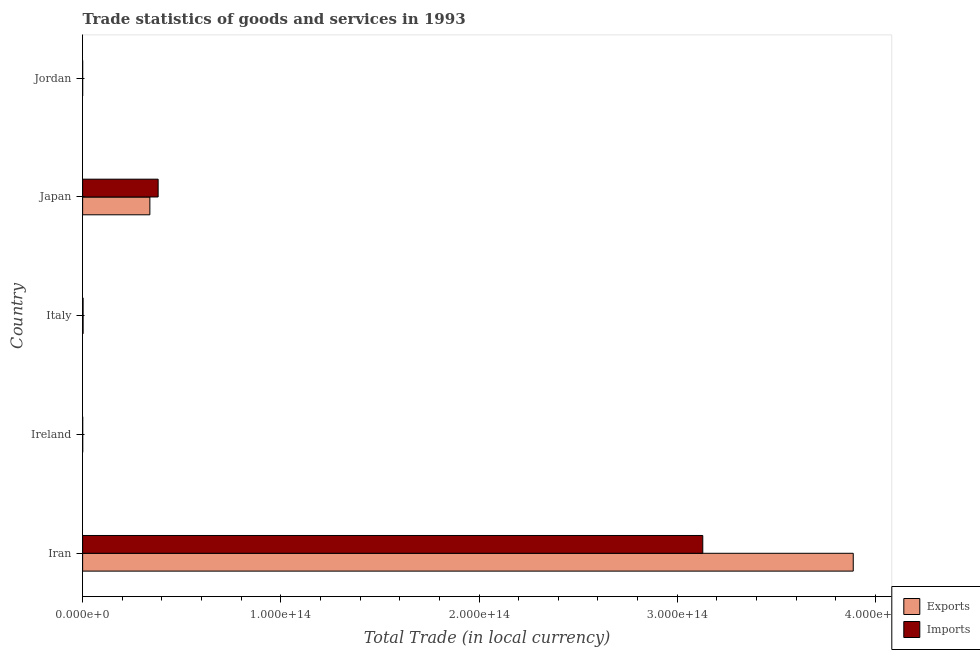How many different coloured bars are there?
Your response must be concise. 2. How many groups of bars are there?
Provide a short and direct response. 5. Are the number of bars on each tick of the Y-axis equal?
Your answer should be compact. Yes. How many bars are there on the 2nd tick from the top?
Provide a succinct answer. 2. How many bars are there on the 1st tick from the bottom?
Ensure brevity in your answer.  2. What is the label of the 4th group of bars from the top?
Keep it short and to the point. Ireland. In how many cases, is the number of bars for a given country not equal to the number of legend labels?
Provide a succinct answer. 0. What is the imports of goods and services in Jordan?
Provide a short and direct response. 3.05e+09. Across all countries, what is the maximum imports of goods and services?
Make the answer very short. 3.13e+14. Across all countries, what is the minimum export of goods and services?
Provide a short and direct response. 2.01e+09. In which country was the imports of goods and services maximum?
Keep it short and to the point. Iran. In which country was the export of goods and services minimum?
Your answer should be very brief. Jordan. What is the total export of goods and services in the graph?
Your answer should be very brief. 4.23e+14. What is the difference between the export of goods and services in Ireland and that in Italy?
Make the answer very short. -2.11e+11. What is the difference between the export of goods and services in Japan and the imports of goods and services in Jordan?
Give a very brief answer. 3.39e+13. What is the average imports of goods and services per country?
Provide a succinct answer. 7.02e+13. What is the difference between the export of goods and services and imports of goods and services in Iran?
Offer a terse response. 7.59e+13. In how many countries, is the export of goods and services greater than 40000000000000 LCU?
Your answer should be compact. 1. What is the ratio of the imports of goods and services in Ireland to that in Italy?
Ensure brevity in your answer.  0.14. What is the difference between the highest and the second highest export of goods and services?
Offer a terse response. 3.55e+14. What is the difference between the highest and the lowest export of goods and services?
Your response must be concise. 3.89e+14. Is the sum of the export of goods and services in Italy and Jordan greater than the maximum imports of goods and services across all countries?
Give a very brief answer. No. What does the 1st bar from the top in Iran represents?
Offer a very short reply. Imports. What does the 1st bar from the bottom in Japan represents?
Offer a terse response. Exports. How many bars are there?
Give a very brief answer. 10. Are all the bars in the graph horizontal?
Offer a terse response. Yes. What is the difference between two consecutive major ticks on the X-axis?
Offer a very short reply. 1.00e+14. Are the values on the major ticks of X-axis written in scientific E-notation?
Your answer should be compact. Yes. Does the graph contain any zero values?
Your response must be concise. No. What is the title of the graph?
Give a very brief answer. Trade statistics of goods and services in 1993. What is the label or title of the X-axis?
Give a very brief answer. Total Trade (in local currency). What is the label or title of the Y-axis?
Your answer should be very brief. Country. What is the Total Trade (in local currency) of Exports in Iran?
Your response must be concise. 3.89e+14. What is the Total Trade (in local currency) of Imports in Iran?
Offer a terse response. 3.13e+14. What is the Total Trade (in local currency) of Exports in Ireland?
Provide a succinct answer. 3.36e+1. What is the Total Trade (in local currency) of Imports in Ireland?
Provide a succinct answer. 3.10e+1. What is the Total Trade (in local currency) of Exports in Italy?
Offer a terse response. 2.44e+11. What is the Total Trade (in local currency) of Imports in Italy?
Your response must be concise. 2.23e+11. What is the Total Trade (in local currency) in Exports in Japan?
Your answer should be compact. 3.39e+13. What is the Total Trade (in local currency) of Imports in Japan?
Provide a short and direct response. 3.81e+13. What is the Total Trade (in local currency) in Exports in Jordan?
Your response must be concise. 2.01e+09. What is the Total Trade (in local currency) in Imports in Jordan?
Provide a short and direct response. 3.05e+09. Across all countries, what is the maximum Total Trade (in local currency) of Exports?
Your response must be concise. 3.89e+14. Across all countries, what is the maximum Total Trade (in local currency) of Imports?
Provide a short and direct response. 3.13e+14. Across all countries, what is the minimum Total Trade (in local currency) in Exports?
Your answer should be compact. 2.01e+09. Across all countries, what is the minimum Total Trade (in local currency) of Imports?
Provide a short and direct response. 3.05e+09. What is the total Total Trade (in local currency) of Exports in the graph?
Your response must be concise. 4.23e+14. What is the total Total Trade (in local currency) in Imports in the graph?
Provide a short and direct response. 3.51e+14. What is the difference between the Total Trade (in local currency) in Exports in Iran and that in Ireland?
Your answer should be compact. 3.89e+14. What is the difference between the Total Trade (in local currency) of Imports in Iran and that in Ireland?
Offer a terse response. 3.13e+14. What is the difference between the Total Trade (in local currency) of Exports in Iran and that in Italy?
Make the answer very short. 3.89e+14. What is the difference between the Total Trade (in local currency) of Imports in Iran and that in Italy?
Give a very brief answer. 3.13e+14. What is the difference between the Total Trade (in local currency) in Exports in Iran and that in Japan?
Your answer should be compact. 3.55e+14. What is the difference between the Total Trade (in local currency) of Imports in Iran and that in Japan?
Make the answer very short. 2.75e+14. What is the difference between the Total Trade (in local currency) in Exports in Iran and that in Jordan?
Make the answer very short. 3.89e+14. What is the difference between the Total Trade (in local currency) in Imports in Iran and that in Jordan?
Your answer should be compact. 3.13e+14. What is the difference between the Total Trade (in local currency) in Exports in Ireland and that in Italy?
Make the answer very short. -2.11e+11. What is the difference between the Total Trade (in local currency) of Imports in Ireland and that in Italy?
Keep it short and to the point. -1.92e+11. What is the difference between the Total Trade (in local currency) in Exports in Ireland and that in Japan?
Provide a short and direct response. -3.39e+13. What is the difference between the Total Trade (in local currency) in Imports in Ireland and that in Japan?
Your answer should be very brief. -3.81e+13. What is the difference between the Total Trade (in local currency) of Exports in Ireland and that in Jordan?
Keep it short and to the point. 3.16e+1. What is the difference between the Total Trade (in local currency) of Imports in Ireland and that in Jordan?
Offer a terse response. 2.79e+1. What is the difference between the Total Trade (in local currency) of Exports in Italy and that in Japan?
Ensure brevity in your answer.  -3.37e+13. What is the difference between the Total Trade (in local currency) in Imports in Italy and that in Japan?
Offer a very short reply. -3.79e+13. What is the difference between the Total Trade (in local currency) of Exports in Italy and that in Jordan?
Your answer should be compact. 2.42e+11. What is the difference between the Total Trade (in local currency) in Imports in Italy and that in Jordan?
Offer a very short reply. 2.20e+11. What is the difference between the Total Trade (in local currency) in Exports in Japan and that in Jordan?
Provide a short and direct response. 3.39e+13. What is the difference between the Total Trade (in local currency) in Imports in Japan and that in Jordan?
Provide a short and direct response. 3.81e+13. What is the difference between the Total Trade (in local currency) of Exports in Iran and the Total Trade (in local currency) of Imports in Ireland?
Your answer should be very brief. 3.89e+14. What is the difference between the Total Trade (in local currency) in Exports in Iran and the Total Trade (in local currency) in Imports in Italy?
Offer a terse response. 3.89e+14. What is the difference between the Total Trade (in local currency) of Exports in Iran and the Total Trade (in local currency) of Imports in Japan?
Give a very brief answer. 3.51e+14. What is the difference between the Total Trade (in local currency) in Exports in Iran and the Total Trade (in local currency) in Imports in Jordan?
Provide a succinct answer. 3.89e+14. What is the difference between the Total Trade (in local currency) of Exports in Ireland and the Total Trade (in local currency) of Imports in Italy?
Give a very brief answer. -1.90e+11. What is the difference between the Total Trade (in local currency) of Exports in Ireland and the Total Trade (in local currency) of Imports in Japan?
Ensure brevity in your answer.  -3.81e+13. What is the difference between the Total Trade (in local currency) in Exports in Ireland and the Total Trade (in local currency) in Imports in Jordan?
Your response must be concise. 3.05e+1. What is the difference between the Total Trade (in local currency) in Exports in Italy and the Total Trade (in local currency) in Imports in Japan?
Offer a very short reply. -3.78e+13. What is the difference between the Total Trade (in local currency) in Exports in Italy and the Total Trade (in local currency) in Imports in Jordan?
Provide a short and direct response. 2.41e+11. What is the difference between the Total Trade (in local currency) in Exports in Japan and the Total Trade (in local currency) in Imports in Jordan?
Offer a terse response. 3.39e+13. What is the average Total Trade (in local currency) of Exports per country?
Your response must be concise. 8.46e+13. What is the average Total Trade (in local currency) of Imports per country?
Give a very brief answer. 7.02e+13. What is the difference between the Total Trade (in local currency) in Exports and Total Trade (in local currency) in Imports in Iran?
Your answer should be compact. 7.59e+13. What is the difference between the Total Trade (in local currency) in Exports and Total Trade (in local currency) in Imports in Ireland?
Offer a very short reply. 2.61e+09. What is the difference between the Total Trade (in local currency) of Exports and Total Trade (in local currency) of Imports in Italy?
Your answer should be very brief. 2.07e+1. What is the difference between the Total Trade (in local currency) in Exports and Total Trade (in local currency) in Imports in Japan?
Make the answer very short. -4.16e+12. What is the difference between the Total Trade (in local currency) of Exports and Total Trade (in local currency) of Imports in Jordan?
Offer a terse response. -1.04e+09. What is the ratio of the Total Trade (in local currency) of Exports in Iran to that in Ireland?
Provide a succinct answer. 1.16e+04. What is the ratio of the Total Trade (in local currency) of Imports in Iran to that in Ireland?
Keep it short and to the point. 1.01e+04. What is the ratio of the Total Trade (in local currency) in Exports in Iran to that in Italy?
Provide a succinct answer. 1592.36. What is the ratio of the Total Trade (in local currency) in Imports in Iran to that in Italy?
Provide a succinct answer. 1400.27. What is the ratio of the Total Trade (in local currency) of Exports in Iran to that in Japan?
Keep it short and to the point. 11.46. What is the ratio of the Total Trade (in local currency) in Imports in Iran to that in Japan?
Keep it short and to the point. 8.21. What is the ratio of the Total Trade (in local currency) of Exports in Iran to that in Jordan?
Your answer should be very brief. 1.94e+05. What is the ratio of the Total Trade (in local currency) of Imports in Iran to that in Jordan?
Your answer should be very brief. 1.03e+05. What is the ratio of the Total Trade (in local currency) of Exports in Ireland to that in Italy?
Your answer should be compact. 0.14. What is the ratio of the Total Trade (in local currency) in Imports in Ireland to that in Italy?
Make the answer very short. 0.14. What is the ratio of the Total Trade (in local currency) of Exports in Ireland to that in Japan?
Your answer should be very brief. 0. What is the ratio of the Total Trade (in local currency) in Imports in Ireland to that in Japan?
Your answer should be compact. 0. What is the ratio of the Total Trade (in local currency) in Exports in Ireland to that in Jordan?
Your answer should be very brief. 16.75. What is the ratio of the Total Trade (in local currency) in Imports in Ireland to that in Jordan?
Your answer should be compact. 10.16. What is the ratio of the Total Trade (in local currency) of Exports in Italy to that in Japan?
Provide a succinct answer. 0.01. What is the ratio of the Total Trade (in local currency) of Imports in Italy to that in Japan?
Offer a terse response. 0.01. What is the ratio of the Total Trade (in local currency) in Exports in Italy to that in Jordan?
Give a very brief answer. 121.77. What is the ratio of the Total Trade (in local currency) of Imports in Italy to that in Jordan?
Your answer should be compact. 73.28. What is the ratio of the Total Trade (in local currency) of Exports in Japan to that in Jordan?
Ensure brevity in your answer.  1.69e+04. What is the ratio of the Total Trade (in local currency) of Imports in Japan to that in Jordan?
Your answer should be very brief. 1.25e+04. What is the difference between the highest and the second highest Total Trade (in local currency) of Exports?
Offer a very short reply. 3.55e+14. What is the difference between the highest and the second highest Total Trade (in local currency) of Imports?
Offer a very short reply. 2.75e+14. What is the difference between the highest and the lowest Total Trade (in local currency) in Exports?
Make the answer very short. 3.89e+14. What is the difference between the highest and the lowest Total Trade (in local currency) of Imports?
Your answer should be very brief. 3.13e+14. 